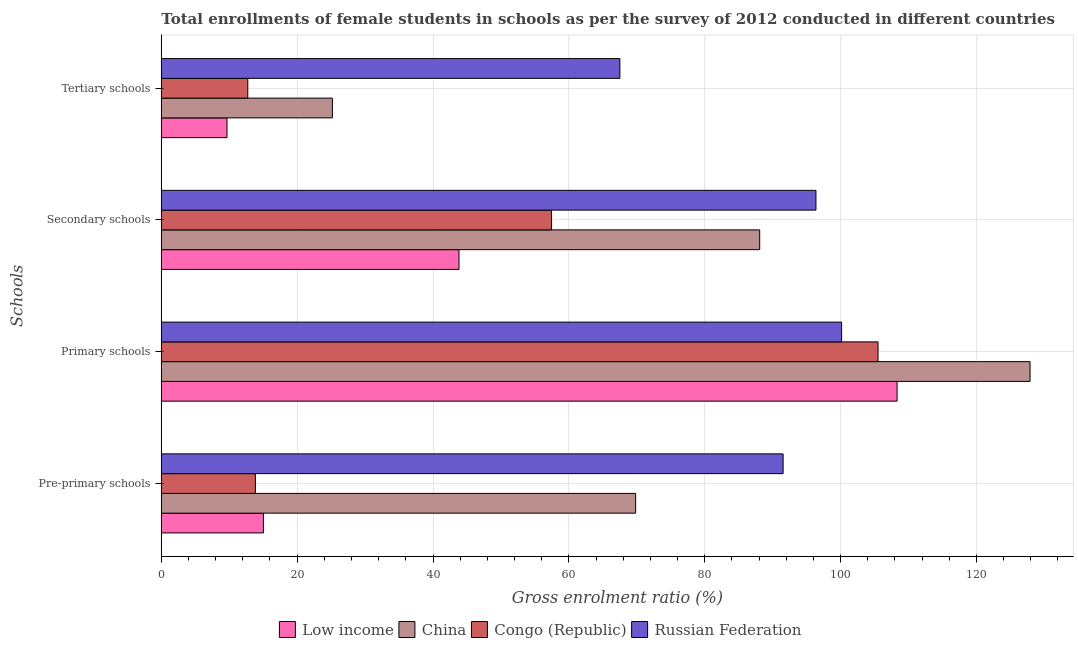How many different coloured bars are there?
Keep it short and to the point. 4. How many bars are there on the 4th tick from the top?
Your answer should be very brief. 4. How many bars are there on the 2nd tick from the bottom?
Keep it short and to the point. 4. What is the label of the 2nd group of bars from the top?
Give a very brief answer. Secondary schools. What is the gross enrolment ratio(female) in pre-primary schools in Congo (Republic)?
Provide a short and direct response. 13.85. Across all countries, what is the maximum gross enrolment ratio(female) in primary schools?
Ensure brevity in your answer.  127.91. Across all countries, what is the minimum gross enrolment ratio(female) in secondary schools?
Your response must be concise. 43.83. In which country was the gross enrolment ratio(female) in primary schools maximum?
Ensure brevity in your answer.  China. In which country was the gross enrolment ratio(female) in pre-primary schools minimum?
Keep it short and to the point. Congo (Republic). What is the total gross enrolment ratio(female) in primary schools in the graph?
Your answer should be very brief. 441.92. What is the difference between the gross enrolment ratio(female) in pre-primary schools in Russian Federation and that in Congo (Republic)?
Ensure brevity in your answer.  77.7. What is the difference between the gross enrolment ratio(female) in primary schools in Congo (Republic) and the gross enrolment ratio(female) in pre-primary schools in China?
Your response must be concise. 35.69. What is the average gross enrolment ratio(female) in secondary schools per country?
Your response must be concise. 71.44. What is the difference between the gross enrolment ratio(female) in pre-primary schools and gross enrolment ratio(female) in tertiary schools in Congo (Republic)?
Your answer should be compact. 1.12. What is the ratio of the gross enrolment ratio(female) in pre-primary schools in Russian Federation to that in China?
Provide a short and direct response. 1.31. What is the difference between the highest and the second highest gross enrolment ratio(female) in tertiary schools?
Ensure brevity in your answer.  42.32. What is the difference between the highest and the lowest gross enrolment ratio(female) in secondary schools?
Your response must be concise. 52.56. Is the sum of the gross enrolment ratio(female) in secondary schools in Russian Federation and Low income greater than the maximum gross enrolment ratio(female) in pre-primary schools across all countries?
Offer a terse response. Yes. What does the 4th bar from the top in Pre-primary schools represents?
Keep it short and to the point. Low income. What does the 4th bar from the bottom in Tertiary schools represents?
Offer a terse response. Russian Federation. How many countries are there in the graph?
Provide a short and direct response. 4. What is the difference between two consecutive major ticks on the X-axis?
Give a very brief answer. 20. Does the graph contain any zero values?
Ensure brevity in your answer.  No. Does the graph contain grids?
Your answer should be very brief. Yes. What is the title of the graph?
Your answer should be very brief. Total enrollments of female students in schools as per the survey of 2012 conducted in different countries. What is the label or title of the X-axis?
Keep it short and to the point. Gross enrolment ratio (%). What is the label or title of the Y-axis?
Provide a succinct answer. Schools. What is the Gross enrolment ratio (%) of Low income in Pre-primary schools?
Provide a succinct answer. 15.03. What is the Gross enrolment ratio (%) of China in Pre-primary schools?
Your answer should be compact. 69.83. What is the Gross enrolment ratio (%) of Congo (Republic) in Pre-primary schools?
Make the answer very short. 13.85. What is the Gross enrolment ratio (%) in Russian Federation in Pre-primary schools?
Ensure brevity in your answer.  91.55. What is the Gross enrolment ratio (%) of Low income in Primary schools?
Offer a terse response. 108.33. What is the Gross enrolment ratio (%) in China in Primary schools?
Give a very brief answer. 127.91. What is the Gross enrolment ratio (%) of Congo (Republic) in Primary schools?
Your answer should be very brief. 105.53. What is the Gross enrolment ratio (%) in Russian Federation in Primary schools?
Your answer should be compact. 100.16. What is the Gross enrolment ratio (%) in Low income in Secondary schools?
Give a very brief answer. 43.83. What is the Gross enrolment ratio (%) of China in Secondary schools?
Provide a short and direct response. 88.1. What is the Gross enrolment ratio (%) in Congo (Republic) in Secondary schools?
Offer a terse response. 57.46. What is the Gross enrolment ratio (%) of Russian Federation in Secondary schools?
Offer a terse response. 96.38. What is the Gross enrolment ratio (%) in Low income in Tertiary schools?
Your answer should be compact. 9.67. What is the Gross enrolment ratio (%) of China in Tertiary schools?
Keep it short and to the point. 25.19. What is the Gross enrolment ratio (%) in Congo (Republic) in Tertiary schools?
Offer a terse response. 12.73. What is the Gross enrolment ratio (%) of Russian Federation in Tertiary schools?
Provide a short and direct response. 67.51. Across all Schools, what is the maximum Gross enrolment ratio (%) of Low income?
Provide a short and direct response. 108.33. Across all Schools, what is the maximum Gross enrolment ratio (%) of China?
Your answer should be very brief. 127.91. Across all Schools, what is the maximum Gross enrolment ratio (%) in Congo (Republic)?
Give a very brief answer. 105.53. Across all Schools, what is the maximum Gross enrolment ratio (%) of Russian Federation?
Your answer should be very brief. 100.16. Across all Schools, what is the minimum Gross enrolment ratio (%) in Low income?
Offer a terse response. 9.67. Across all Schools, what is the minimum Gross enrolment ratio (%) in China?
Offer a terse response. 25.19. Across all Schools, what is the minimum Gross enrolment ratio (%) of Congo (Republic)?
Keep it short and to the point. 12.73. Across all Schools, what is the minimum Gross enrolment ratio (%) of Russian Federation?
Offer a terse response. 67.51. What is the total Gross enrolment ratio (%) in Low income in the graph?
Your answer should be compact. 176.86. What is the total Gross enrolment ratio (%) of China in the graph?
Give a very brief answer. 311.03. What is the total Gross enrolment ratio (%) in Congo (Republic) in the graph?
Provide a short and direct response. 189.56. What is the total Gross enrolment ratio (%) of Russian Federation in the graph?
Keep it short and to the point. 355.61. What is the difference between the Gross enrolment ratio (%) of Low income in Pre-primary schools and that in Primary schools?
Your response must be concise. -93.3. What is the difference between the Gross enrolment ratio (%) of China in Pre-primary schools and that in Primary schools?
Keep it short and to the point. -58.07. What is the difference between the Gross enrolment ratio (%) in Congo (Republic) in Pre-primary schools and that in Primary schools?
Your answer should be very brief. -91.67. What is the difference between the Gross enrolment ratio (%) in Russian Federation in Pre-primary schools and that in Primary schools?
Offer a terse response. -8.61. What is the difference between the Gross enrolment ratio (%) in Low income in Pre-primary schools and that in Secondary schools?
Give a very brief answer. -28.79. What is the difference between the Gross enrolment ratio (%) of China in Pre-primary schools and that in Secondary schools?
Make the answer very short. -18.27. What is the difference between the Gross enrolment ratio (%) of Congo (Republic) in Pre-primary schools and that in Secondary schools?
Your answer should be compact. -43.6. What is the difference between the Gross enrolment ratio (%) in Russian Federation in Pre-primary schools and that in Secondary schools?
Your response must be concise. -4.84. What is the difference between the Gross enrolment ratio (%) of Low income in Pre-primary schools and that in Tertiary schools?
Provide a short and direct response. 5.36. What is the difference between the Gross enrolment ratio (%) in China in Pre-primary schools and that in Tertiary schools?
Offer a terse response. 44.64. What is the difference between the Gross enrolment ratio (%) in Congo (Republic) in Pre-primary schools and that in Tertiary schools?
Make the answer very short. 1.12. What is the difference between the Gross enrolment ratio (%) of Russian Federation in Pre-primary schools and that in Tertiary schools?
Ensure brevity in your answer.  24.03. What is the difference between the Gross enrolment ratio (%) in Low income in Primary schools and that in Secondary schools?
Offer a very short reply. 64.5. What is the difference between the Gross enrolment ratio (%) of China in Primary schools and that in Secondary schools?
Your response must be concise. 39.81. What is the difference between the Gross enrolment ratio (%) of Congo (Republic) in Primary schools and that in Secondary schools?
Provide a short and direct response. 48.07. What is the difference between the Gross enrolment ratio (%) in Russian Federation in Primary schools and that in Secondary schools?
Offer a terse response. 3.78. What is the difference between the Gross enrolment ratio (%) in Low income in Primary schools and that in Tertiary schools?
Your response must be concise. 98.66. What is the difference between the Gross enrolment ratio (%) in China in Primary schools and that in Tertiary schools?
Make the answer very short. 102.72. What is the difference between the Gross enrolment ratio (%) in Congo (Republic) in Primary schools and that in Tertiary schools?
Offer a terse response. 92.79. What is the difference between the Gross enrolment ratio (%) of Russian Federation in Primary schools and that in Tertiary schools?
Offer a terse response. 32.65. What is the difference between the Gross enrolment ratio (%) of Low income in Secondary schools and that in Tertiary schools?
Provide a succinct answer. 34.16. What is the difference between the Gross enrolment ratio (%) in China in Secondary schools and that in Tertiary schools?
Give a very brief answer. 62.91. What is the difference between the Gross enrolment ratio (%) of Congo (Republic) in Secondary schools and that in Tertiary schools?
Give a very brief answer. 44.72. What is the difference between the Gross enrolment ratio (%) in Russian Federation in Secondary schools and that in Tertiary schools?
Keep it short and to the point. 28.87. What is the difference between the Gross enrolment ratio (%) of Low income in Pre-primary schools and the Gross enrolment ratio (%) of China in Primary schools?
Keep it short and to the point. -112.87. What is the difference between the Gross enrolment ratio (%) of Low income in Pre-primary schools and the Gross enrolment ratio (%) of Congo (Republic) in Primary schools?
Ensure brevity in your answer.  -90.49. What is the difference between the Gross enrolment ratio (%) in Low income in Pre-primary schools and the Gross enrolment ratio (%) in Russian Federation in Primary schools?
Offer a terse response. -85.13. What is the difference between the Gross enrolment ratio (%) in China in Pre-primary schools and the Gross enrolment ratio (%) in Congo (Republic) in Primary schools?
Make the answer very short. -35.69. What is the difference between the Gross enrolment ratio (%) in China in Pre-primary schools and the Gross enrolment ratio (%) in Russian Federation in Primary schools?
Provide a short and direct response. -30.33. What is the difference between the Gross enrolment ratio (%) in Congo (Republic) in Pre-primary schools and the Gross enrolment ratio (%) in Russian Federation in Primary schools?
Provide a succinct answer. -86.31. What is the difference between the Gross enrolment ratio (%) of Low income in Pre-primary schools and the Gross enrolment ratio (%) of China in Secondary schools?
Keep it short and to the point. -73.07. What is the difference between the Gross enrolment ratio (%) of Low income in Pre-primary schools and the Gross enrolment ratio (%) of Congo (Republic) in Secondary schools?
Keep it short and to the point. -42.42. What is the difference between the Gross enrolment ratio (%) in Low income in Pre-primary schools and the Gross enrolment ratio (%) in Russian Federation in Secondary schools?
Ensure brevity in your answer.  -81.35. What is the difference between the Gross enrolment ratio (%) of China in Pre-primary schools and the Gross enrolment ratio (%) of Congo (Republic) in Secondary schools?
Your answer should be very brief. 12.38. What is the difference between the Gross enrolment ratio (%) of China in Pre-primary schools and the Gross enrolment ratio (%) of Russian Federation in Secondary schools?
Your response must be concise. -26.55. What is the difference between the Gross enrolment ratio (%) of Congo (Republic) in Pre-primary schools and the Gross enrolment ratio (%) of Russian Federation in Secondary schools?
Offer a very short reply. -82.53. What is the difference between the Gross enrolment ratio (%) of Low income in Pre-primary schools and the Gross enrolment ratio (%) of China in Tertiary schools?
Your answer should be compact. -10.16. What is the difference between the Gross enrolment ratio (%) in Low income in Pre-primary schools and the Gross enrolment ratio (%) in Congo (Republic) in Tertiary schools?
Keep it short and to the point. 2.3. What is the difference between the Gross enrolment ratio (%) in Low income in Pre-primary schools and the Gross enrolment ratio (%) in Russian Federation in Tertiary schools?
Offer a very short reply. -52.48. What is the difference between the Gross enrolment ratio (%) in China in Pre-primary schools and the Gross enrolment ratio (%) in Congo (Republic) in Tertiary schools?
Offer a very short reply. 57.1. What is the difference between the Gross enrolment ratio (%) in China in Pre-primary schools and the Gross enrolment ratio (%) in Russian Federation in Tertiary schools?
Keep it short and to the point. 2.32. What is the difference between the Gross enrolment ratio (%) in Congo (Republic) in Pre-primary schools and the Gross enrolment ratio (%) in Russian Federation in Tertiary schools?
Make the answer very short. -53.66. What is the difference between the Gross enrolment ratio (%) in Low income in Primary schools and the Gross enrolment ratio (%) in China in Secondary schools?
Your response must be concise. 20.23. What is the difference between the Gross enrolment ratio (%) in Low income in Primary schools and the Gross enrolment ratio (%) in Congo (Republic) in Secondary schools?
Offer a very short reply. 50.87. What is the difference between the Gross enrolment ratio (%) of Low income in Primary schools and the Gross enrolment ratio (%) of Russian Federation in Secondary schools?
Your answer should be compact. 11.94. What is the difference between the Gross enrolment ratio (%) of China in Primary schools and the Gross enrolment ratio (%) of Congo (Republic) in Secondary schools?
Your response must be concise. 70.45. What is the difference between the Gross enrolment ratio (%) in China in Primary schools and the Gross enrolment ratio (%) in Russian Federation in Secondary schools?
Provide a short and direct response. 31.52. What is the difference between the Gross enrolment ratio (%) of Congo (Republic) in Primary schools and the Gross enrolment ratio (%) of Russian Federation in Secondary schools?
Give a very brief answer. 9.14. What is the difference between the Gross enrolment ratio (%) of Low income in Primary schools and the Gross enrolment ratio (%) of China in Tertiary schools?
Offer a terse response. 83.14. What is the difference between the Gross enrolment ratio (%) in Low income in Primary schools and the Gross enrolment ratio (%) in Congo (Republic) in Tertiary schools?
Provide a succinct answer. 95.6. What is the difference between the Gross enrolment ratio (%) in Low income in Primary schools and the Gross enrolment ratio (%) in Russian Federation in Tertiary schools?
Provide a short and direct response. 40.82. What is the difference between the Gross enrolment ratio (%) of China in Primary schools and the Gross enrolment ratio (%) of Congo (Republic) in Tertiary schools?
Your response must be concise. 115.18. What is the difference between the Gross enrolment ratio (%) in China in Primary schools and the Gross enrolment ratio (%) in Russian Federation in Tertiary schools?
Offer a very short reply. 60.39. What is the difference between the Gross enrolment ratio (%) in Congo (Republic) in Primary schools and the Gross enrolment ratio (%) in Russian Federation in Tertiary schools?
Make the answer very short. 38.01. What is the difference between the Gross enrolment ratio (%) of Low income in Secondary schools and the Gross enrolment ratio (%) of China in Tertiary schools?
Your response must be concise. 18.64. What is the difference between the Gross enrolment ratio (%) of Low income in Secondary schools and the Gross enrolment ratio (%) of Congo (Republic) in Tertiary schools?
Keep it short and to the point. 31.1. What is the difference between the Gross enrolment ratio (%) of Low income in Secondary schools and the Gross enrolment ratio (%) of Russian Federation in Tertiary schools?
Your answer should be very brief. -23.69. What is the difference between the Gross enrolment ratio (%) of China in Secondary schools and the Gross enrolment ratio (%) of Congo (Republic) in Tertiary schools?
Keep it short and to the point. 75.37. What is the difference between the Gross enrolment ratio (%) in China in Secondary schools and the Gross enrolment ratio (%) in Russian Federation in Tertiary schools?
Your answer should be compact. 20.59. What is the difference between the Gross enrolment ratio (%) of Congo (Republic) in Secondary schools and the Gross enrolment ratio (%) of Russian Federation in Tertiary schools?
Offer a very short reply. -10.06. What is the average Gross enrolment ratio (%) of Low income per Schools?
Offer a terse response. 44.22. What is the average Gross enrolment ratio (%) in China per Schools?
Give a very brief answer. 77.76. What is the average Gross enrolment ratio (%) of Congo (Republic) per Schools?
Your response must be concise. 47.39. What is the average Gross enrolment ratio (%) in Russian Federation per Schools?
Your answer should be compact. 88.9. What is the difference between the Gross enrolment ratio (%) of Low income and Gross enrolment ratio (%) of China in Pre-primary schools?
Offer a terse response. -54.8. What is the difference between the Gross enrolment ratio (%) of Low income and Gross enrolment ratio (%) of Congo (Republic) in Pre-primary schools?
Offer a very short reply. 1.18. What is the difference between the Gross enrolment ratio (%) of Low income and Gross enrolment ratio (%) of Russian Federation in Pre-primary schools?
Offer a very short reply. -76.52. What is the difference between the Gross enrolment ratio (%) of China and Gross enrolment ratio (%) of Congo (Republic) in Pre-primary schools?
Make the answer very short. 55.98. What is the difference between the Gross enrolment ratio (%) in China and Gross enrolment ratio (%) in Russian Federation in Pre-primary schools?
Offer a very short reply. -21.71. What is the difference between the Gross enrolment ratio (%) of Congo (Republic) and Gross enrolment ratio (%) of Russian Federation in Pre-primary schools?
Your answer should be compact. -77.7. What is the difference between the Gross enrolment ratio (%) of Low income and Gross enrolment ratio (%) of China in Primary schools?
Your answer should be very brief. -19.58. What is the difference between the Gross enrolment ratio (%) of Low income and Gross enrolment ratio (%) of Congo (Republic) in Primary schools?
Provide a succinct answer. 2.8. What is the difference between the Gross enrolment ratio (%) in Low income and Gross enrolment ratio (%) in Russian Federation in Primary schools?
Provide a short and direct response. 8.17. What is the difference between the Gross enrolment ratio (%) of China and Gross enrolment ratio (%) of Congo (Republic) in Primary schools?
Provide a short and direct response. 22.38. What is the difference between the Gross enrolment ratio (%) in China and Gross enrolment ratio (%) in Russian Federation in Primary schools?
Keep it short and to the point. 27.75. What is the difference between the Gross enrolment ratio (%) of Congo (Republic) and Gross enrolment ratio (%) of Russian Federation in Primary schools?
Provide a succinct answer. 5.36. What is the difference between the Gross enrolment ratio (%) in Low income and Gross enrolment ratio (%) in China in Secondary schools?
Offer a very short reply. -44.27. What is the difference between the Gross enrolment ratio (%) of Low income and Gross enrolment ratio (%) of Congo (Republic) in Secondary schools?
Make the answer very short. -13.63. What is the difference between the Gross enrolment ratio (%) in Low income and Gross enrolment ratio (%) in Russian Federation in Secondary schools?
Your answer should be very brief. -52.56. What is the difference between the Gross enrolment ratio (%) in China and Gross enrolment ratio (%) in Congo (Republic) in Secondary schools?
Offer a terse response. 30.64. What is the difference between the Gross enrolment ratio (%) in China and Gross enrolment ratio (%) in Russian Federation in Secondary schools?
Your answer should be very brief. -8.28. What is the difference between the Gross enrolment ratio (%) in Congo (Republic) and Gross enrolment ratio (%) in Russian Federation in Secondary schools?
Ensure brevity in your answer.  -38.93. What is the difference between the Gross enrolment ratio (%) of Low income and Gross enrolment ratio (%) of China in Tertiary schools?
Your answer should be very brief. -15.52. What is the difference between the Gross enrolment ratio (%) in Low income and Gross enrolment ratio (%) in Congo (Republic) in Tertiary schools?
Your answer should be compact. -3.06. What is the difference between the Gross enrolment ratio (%) of Low income and Gross enrolment ratio (%) of Russian Federation in Tertiary schools?
Make the answer very short. -57.84. What is the difference between the Gross enrolment ratio (%) in China and Gross enrolment ratio (%) in Congo (Republic) in Tertiary schools?
Offer a very short reply. 12.46. What is the difference between the Gross enrolment ratio (%) of China and Gross enrolment ratio (%) of Russian Federation in Tertiary schools?
Offer a very short reply. -42.32. What is the difference between the Gross enrolment ratio (%) of Congo (Republic) and Gross enrolment ratio (%) of Russian Federation in Tertiary schools?
Provide a succinct answer. -54.78. What is the ratio of the Gross enrolment ratio (%) of Low income in Pre-primary schools to that in Primary schools?
Your answer should be compact. 0.14. What is the ratio of the Gross enrolment ratio (%) in China in Pre-primary schools to that in Primary schools?
Provide a succinct answer. 0.55. What is the ratio of the Gross enrolment ratio (%) in Congo (Republic) in Pre-primary schools to that in Primary schools?
Offer a terse response. 0.13. What is the ratio of the Gross enrolment ratio (%) of Russian Federation in Pre-primary schools to that in Primary schools?
Your answer should be very brief. 0.91. What is the ratio of the Gross enrolment ratio (%) of Low income in Pre-primary schools to that in Secondary schools?
Your answer should be compact. 0.34. What is the ratio of the Gross enrolment ratio (%) in China in Pre-primary schools to that in Secondary schools?
Offer a terse response. 0.79. What is the ratio of the Gross enrolment ratio (%) in Congo (Republic) in Pre-primary schools to that in Secondary schools?
Your response must be concise. 0.24. What is the ratio of the Gross enrolment ratio (%) in Russian Federation in Pre-primary schools to that in Secondary schools?
Your response must be concise. 0.95. What is the ratio of the Gross enrolment ratio (%) in Low income in Pre-primary schools to that in Tertiary schools?
Your answer should be compact. 1.55. What is the ratio of the Gross enrolment ratio (%) in China in Pre-primary schools to that in Tertiary schools?
Give a very brief answer. 2.77. What is the ratio of the Gross enrolment ratio (%) of Congo (Republic) in Pre-primary schools to that in Tertiary schools?
Provide a short and direct response. 1.09. What is the ratio of the Gross enrolment ratio (%) of Russian Federation in Pre-primary schools to that in Tertiary schools?
Your response must be concise. 1.36. What is the ratio of the Gross enrolment ratio (%) of Low income in Primary schools to that in Secondary schools?
Provide a short and direct response. 2.47. What is the ratio of the Gross enrolment ratio (%) in China in Primary schools to that in Secondary schools?
Your response must be concise. 1.45. What is the ratio of the Gross enrolment ratio (%) of Congo (Republic) in Primary schools to that in Secondary schools?
Make the answer very short. 1.84. What is the ratio of the Gross enrolment ratio (%) of Russian Federation in Primary schools to that in Secondary schools?
Your answer should be very brief. 1.04. What is the ratio of the Gross enrolment ratio (%) in Low income in Primary schools to that in Tertiary schools?
Offer a very short reply. 11.2. What is the ratio of the Gross enrolment ratio (%) of China in Primary schools to that in Tertiary schools?
Keep it short and to the point. 5.08. What is the ratio of the Gross enrolment ratio (%) in Congo (Republic) in Primary schools to that in Tertiary schools?
Your answer should be very brief. 8.29. What is the ratio of the Gross enrolment ratio (%) in Russian Federation in Primary schools to that in Tertiary schools?
Offer a terse response. 1.48. What is the ratio of the Gross enrolment ratio (%) in Low income in Secondary schools to that in Tertiary schools?
Your response must be concise. 4.53. What is the ratio of the Gross enrolment ratio (%) in China in Secondary schools to that in Tertiary schools?
Your answer should be very brief. 3.5. What is the ratio of the Gross enrolment ratio (%) of Congo (Republic) in Secondary schools to that in Tertiary schools?
Your answer should be compact. 4.51. What is the ratio of the Gross enrolment ratio (%) of Russian Federation in Secondary schools to that in Tertiary schools?
Ensure brevity in your answer.  1.43. What is the difference between the highest and the second highest Gross enrolment ratio (%) in Low income?
Your answer should be very brief. 64.5. What is the difference between the highest and the second highest Gross enrolment ratio (%) in China?
Keep it short and to the point. 39.81. What is the difference between the highest and the second highest Gross enrolment ratio (%) of Congo (Republic)?
Offer a terse response. 48.07. What is the difference between the highest and the second highest Gross enrolment ratio (%) in Russian Federation?
Your answer should be very brief. 3.78. What is the difference between the highest and the lowest Gross enrolment ratio (%) in Low income?
Your answer should be compact. 98.66. What is the difference between the highest and the lowest Gross enrolment ratio (%) in China?
Offer a terse response. 102.72. What is the difference between the highest and the lowest Gross enrolment ratio (%) in Congo (Republic)?
Offer a terse response. 92.79. What is the difference between the highest and the lowest Gross enrolment ratio (%) of Russian Federation?
Provide a short and direct response. 32.65. 